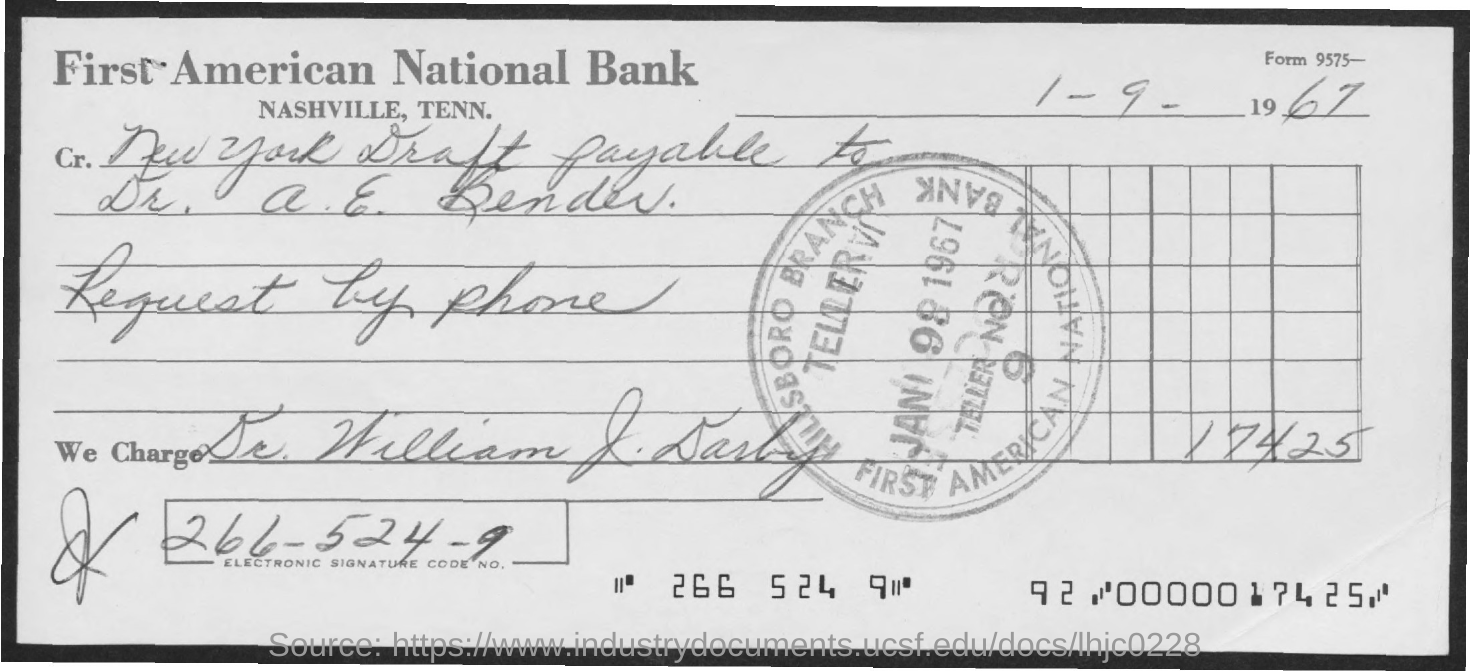What is the electronic signature code no?
Give a very brief answer. 266-524-9. What is the title of the document?
Your answer should be very brief. First American National Bank. What is the date mentioned in the document?
Make the answer very short. 1 - 9 - 1967. 